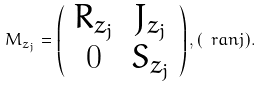Convert formula to latex. <formula><loc_0><loc_0><loc_500><loc_500>M _ { z _ { j } } = \left ( \begin{array} { c c } R _ { z _ { j } } & J _ { z _ { j } } \\ 0 & S _ { z _ { j } } \end{array} \right ) , ( \ r a n { j } ) .</formula> 